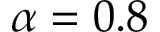<formula> <loc_0><loc_0><loc_500><loc_500>\alpha = 0 . 8</formula> 